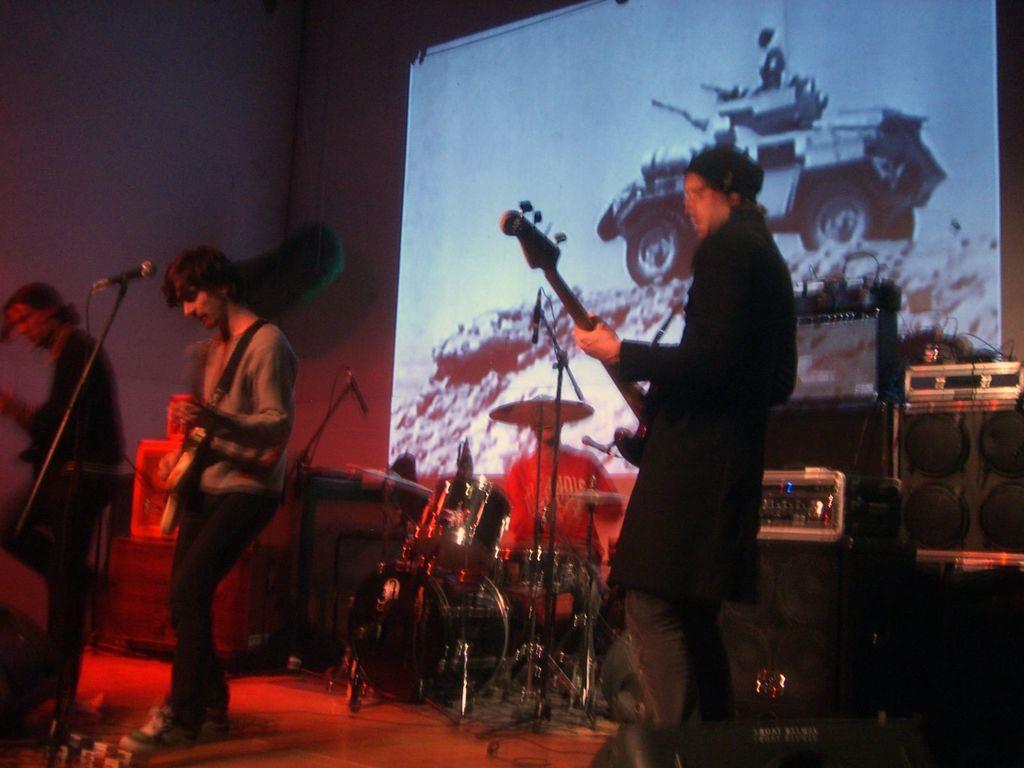Please provide a concise description of this image. In this picture there are three members standing and playing a guitars in their hands in front of a mic. In the background there is another guy playing drums. There are speakers in the right side. There is a projector display screen on the wall here. 